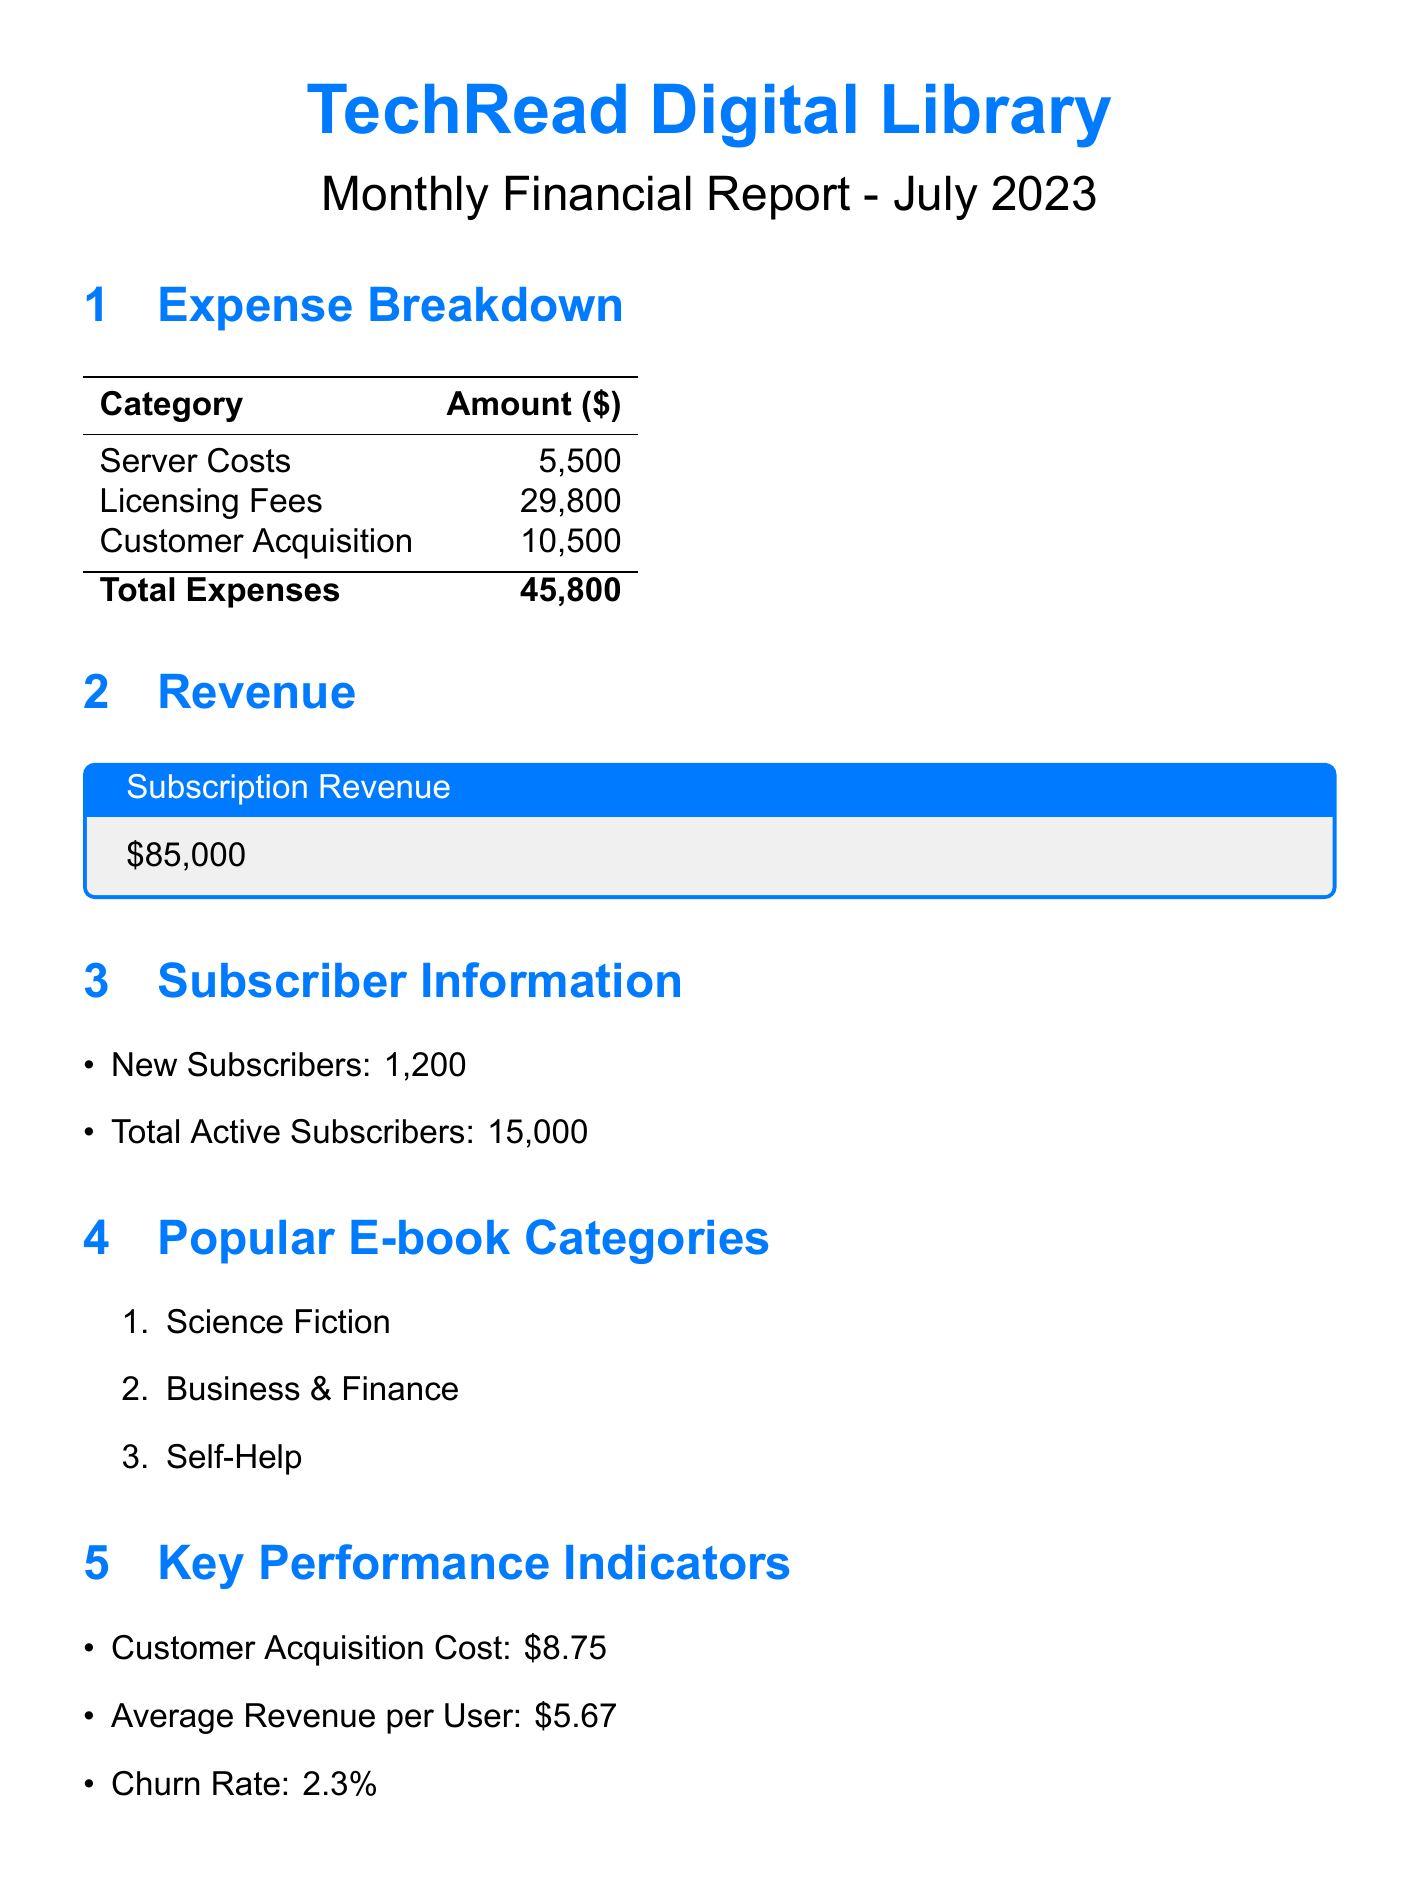what was the total amount spent on server costs? The total amount spent on server costs is the sum of AWS cloud hosting, CDN services, and database management, which is $3200 + $800 + $1500 = $5500.
Answer: $5500 what are the licensing fees paid to Penguin Random House? The licensing fee paid to Penguin Random House is explicitly mentioned in the document as $12000.
Answer: $12000 how many new subscribers were added in July 2023? The document states that 1200 new subscribers were added in July 2023.
Answer: 1200 what is the average revenue per user? The average revenue per user, as per the key performance indicators, is given as $5.67.
Answer: $5.67 what is the total of customer acquisition expenses? The total customer acquisition expenses include Google Ads, Facebook campaigns, influencer partnerships, and email marketing amounting to $4500 + $3200 + $2000 + $800 = $10500.
Answer: $10500 which e-book category is listed first as the most popular? The document lists "Science Fiction" as the first most popular e-book category.
Answer: Science Fiction what is the churn rate mentioned in the report? The churn rate noted in the key performance indicators is stated as 2.3%.
Answer: 2.3% what fraction of the library's future initiatives relates to audiobooks? Out of the three future initiatives, one explicitly mentions expanding the audiobook library, thus the fraction is 1 out of 3.
Answer: 1 out of 3 how much was spent on influencer partnerships for customer acquisition? The amount spent on influencer partnerships is clearly stated as $2000.
Answer: $2000 